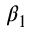Convert formula to latex. <formula><loc_0><loc_0><loc_500><loc_500>\beta _ { 1 }</formula> 